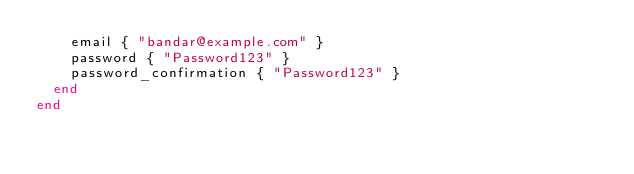Convert code to text. <code><loc_0><loc_0><loc_500><loc_500><_Ruby_>    email { "bandar@example.com" }
    password { "Password123" }
    password_confirmation { "Password123" }
  end
end
</code> 